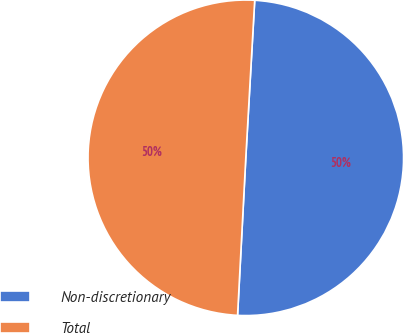Convert chart. <chart><loc_0><loc_0><loc_500><loc_500><pie_chart><fcel>Non-discretionary<fcel>Total<nl><fcel>49.93%<fcel>50.07%<nl></chart> 